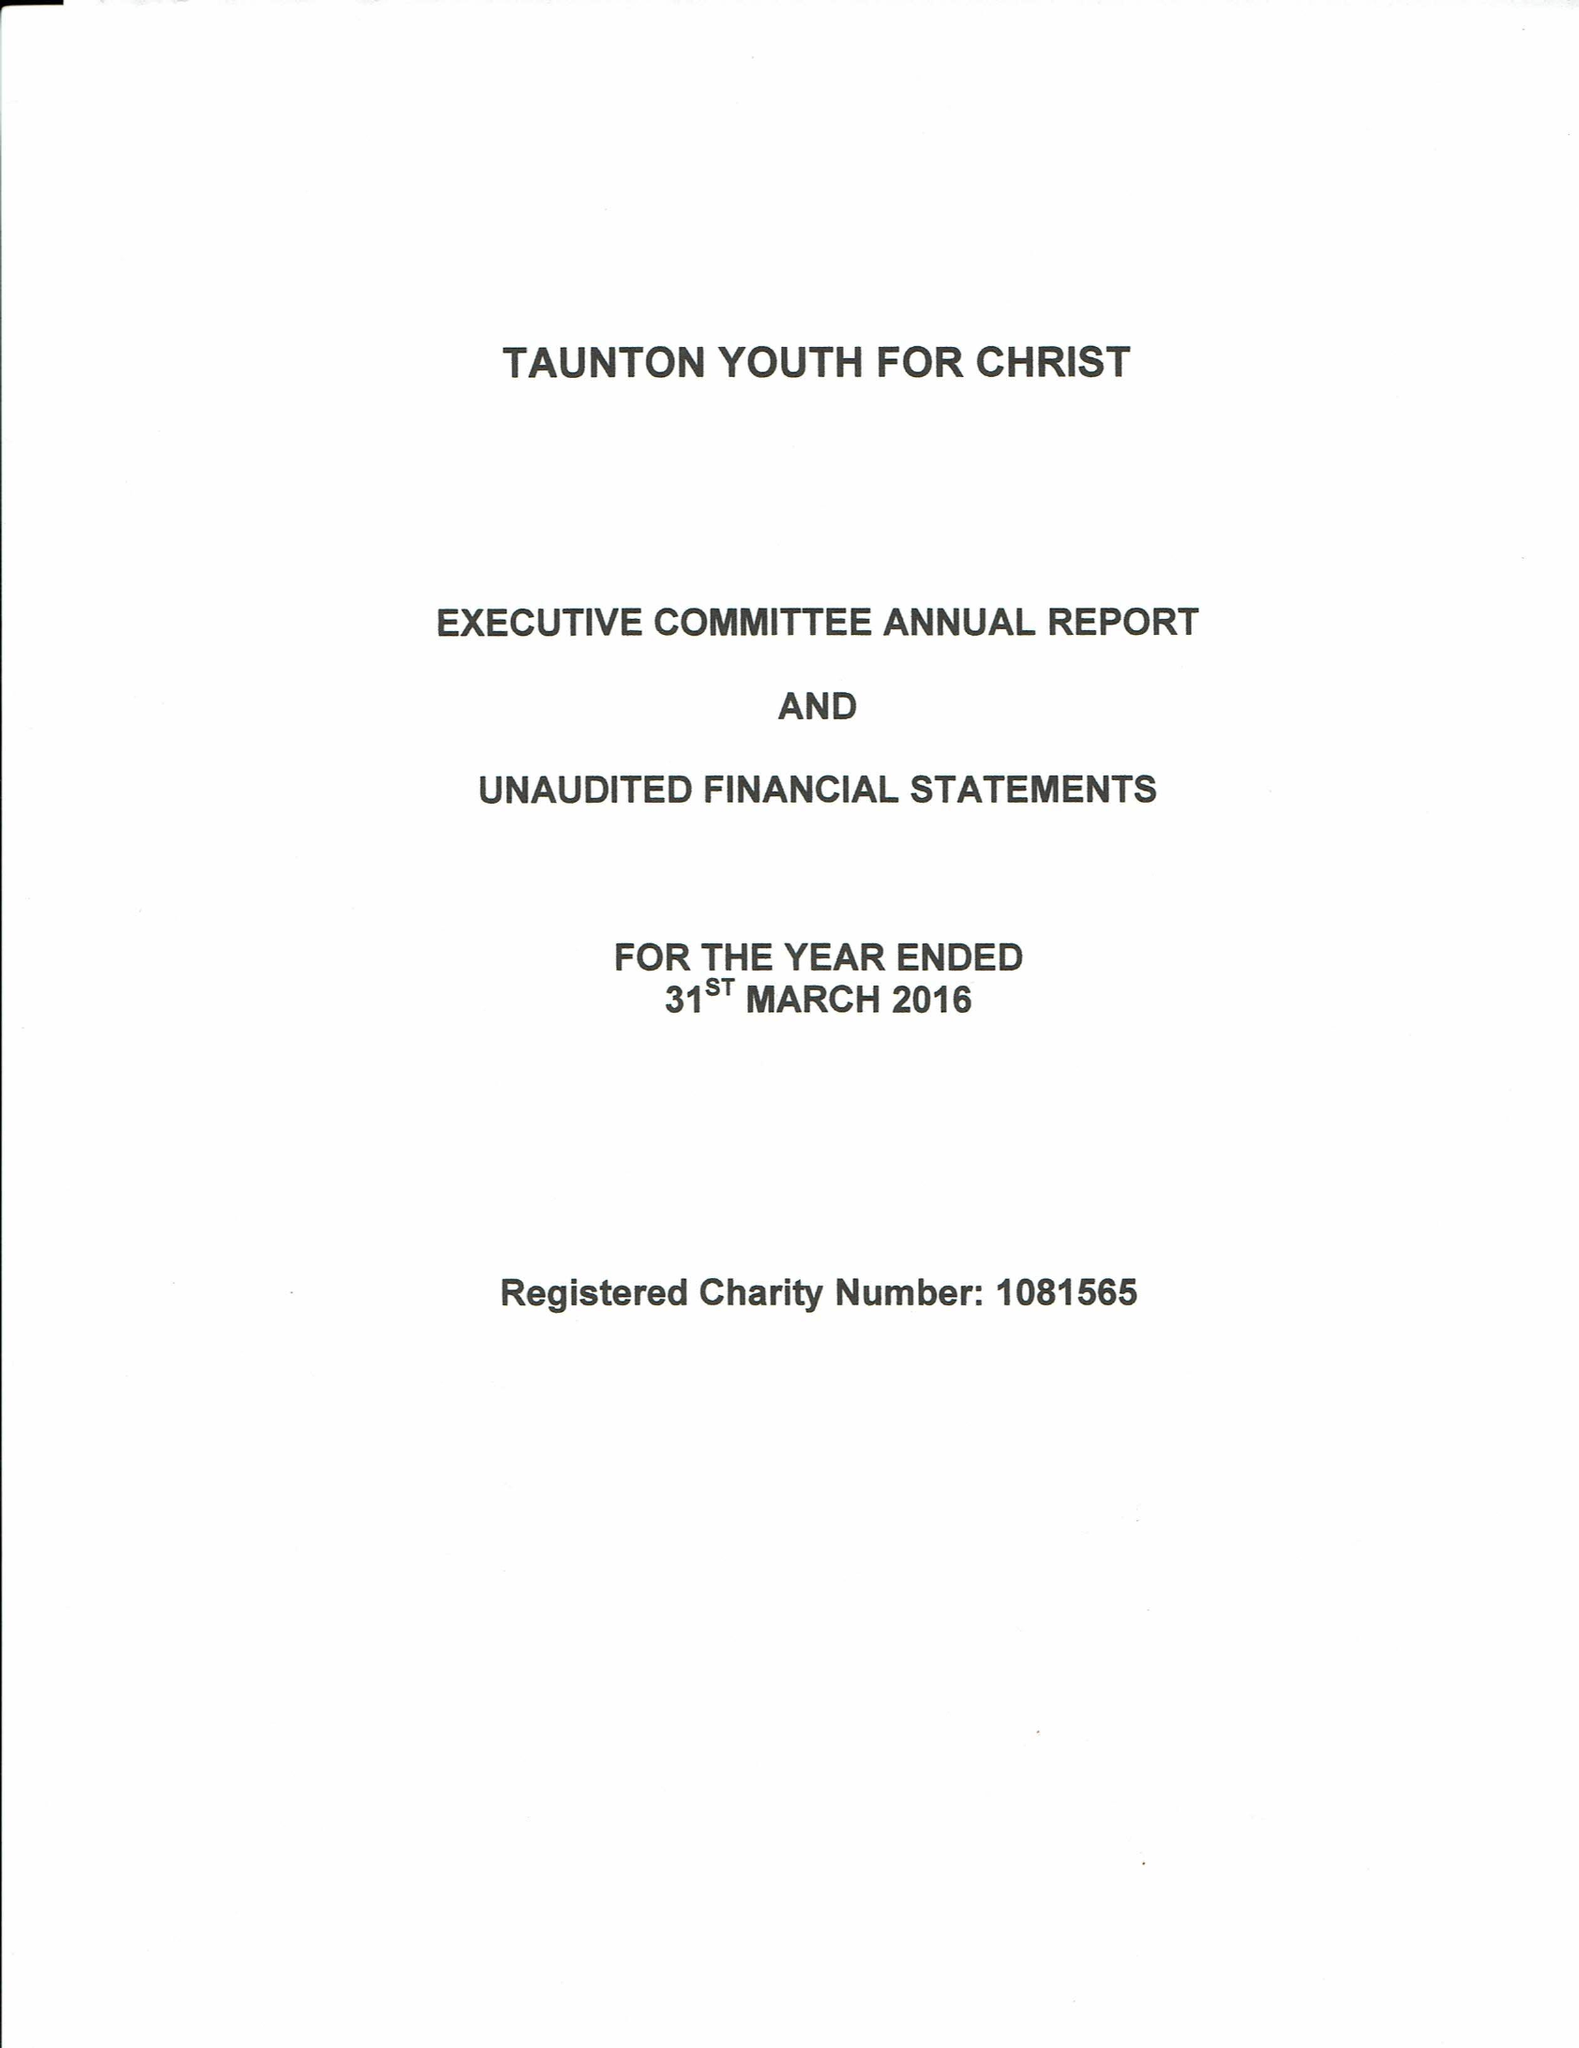What is the value for the address__post_town?
Answer the question using a single word or phrase. TAUNTON 